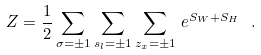Convert formula to latex. <formula><loc_0><loc_0><loc_500><loc_500>Z = \frac { 1 } { 2 } \sum _ { \sigma = \pm 1 } \sum _ { s _ { l } = \pm 1 } \sum _ { z _ { x } = \pm 1 } \, e ^ { S _ { W } + S _ { H } } \ .</formula> 